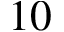<formula> <loc_0><loc_0><loc_500><loc_500>1 0</formula> 